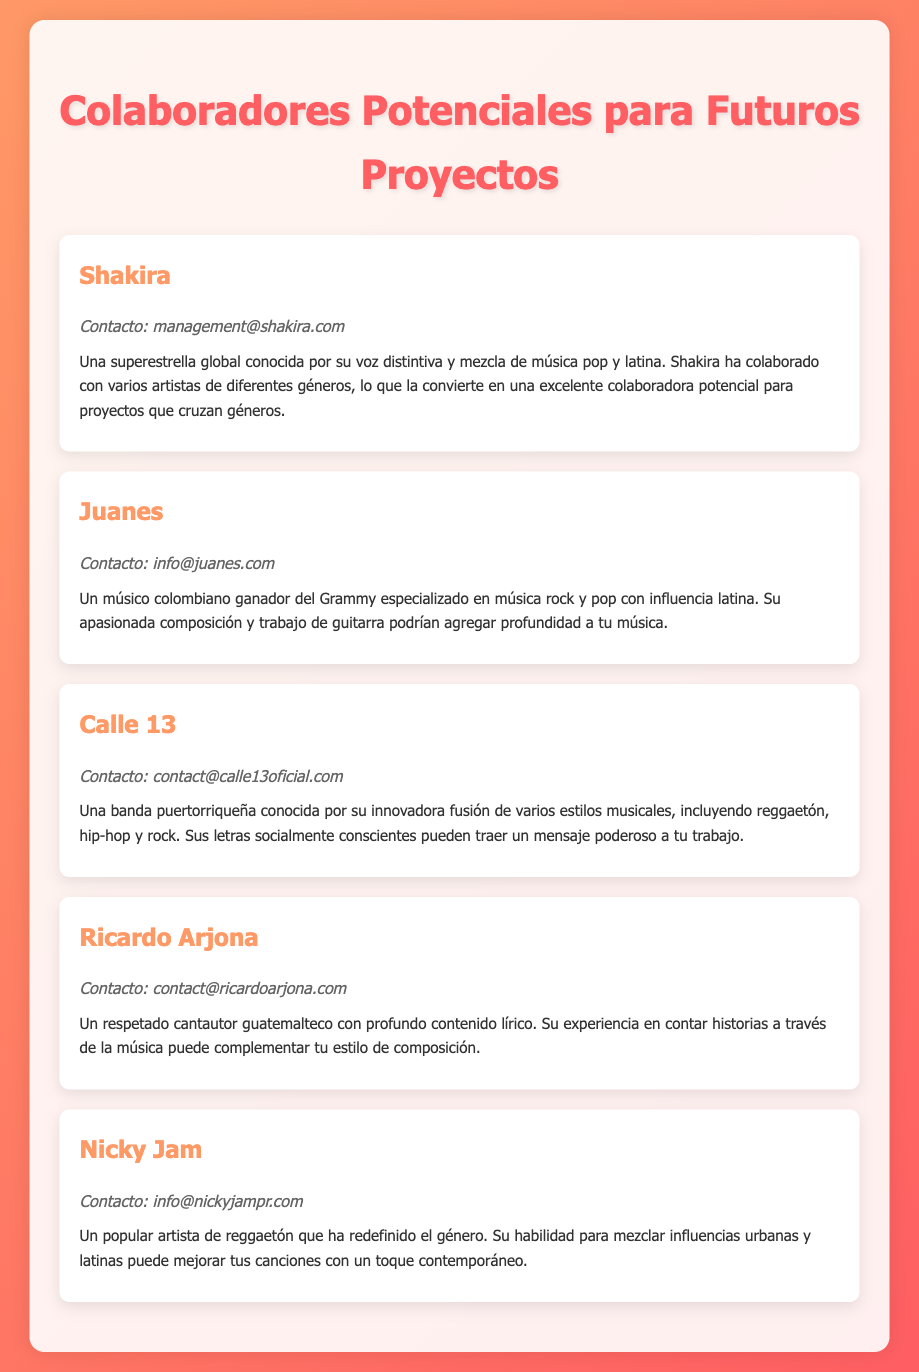¿Qué contacto tiene Shakira? El contacto de Shakira se encuentra en su descripción, que es management@shakira.com.
Answer: management@shakira.com ¿Cuál es el nombre de la banda mencionada en el documento? El documento menciona a Calle 13 como una de las colaboraciones potenciales.
Answer: Calle 13 ¿Cuál es el género musical de Juanes? En la descripción de Juanes se menciona que se especializa en música rock y pop con influencia latina.
Answer: Rock y pop ¿Qué artista es conocido por su habilidad en el reggaetón? Nicky Jam es conocido por ser un popular artista de reggaetón, según su descripción.
Answer: Nicky Jam ¿Qué tipo de letras caracterizan a Calle 13? La descripción de Calle 13 indica que son letras socialmente conscientes.
Answer: Socialmente conscientes ¿Cuántos colaboradores se mencionan en el documento? El documento incluye cinco colaboradores potenciales para futuros proyectos.
Answer: Cinco ¿Cuál es el tema principal de las descripciones? Las descripciones se enfocan en los estilos musicales y las contribuciones potenciales de cada colaborador.
Answer: Estilos musicales y contribuciones ¿Qué contacto tiene Ricardo Arjona? El contacto para Ricardo Arjona se especifica como contact@ricardoarjona.com.
Answer: contact@ricardoarjona.com ¿De qué nacionalidad es Ricardo Arjona? En la descripción se indica que es un cantautor guatemalteco.
Answer: Guatemalteco 